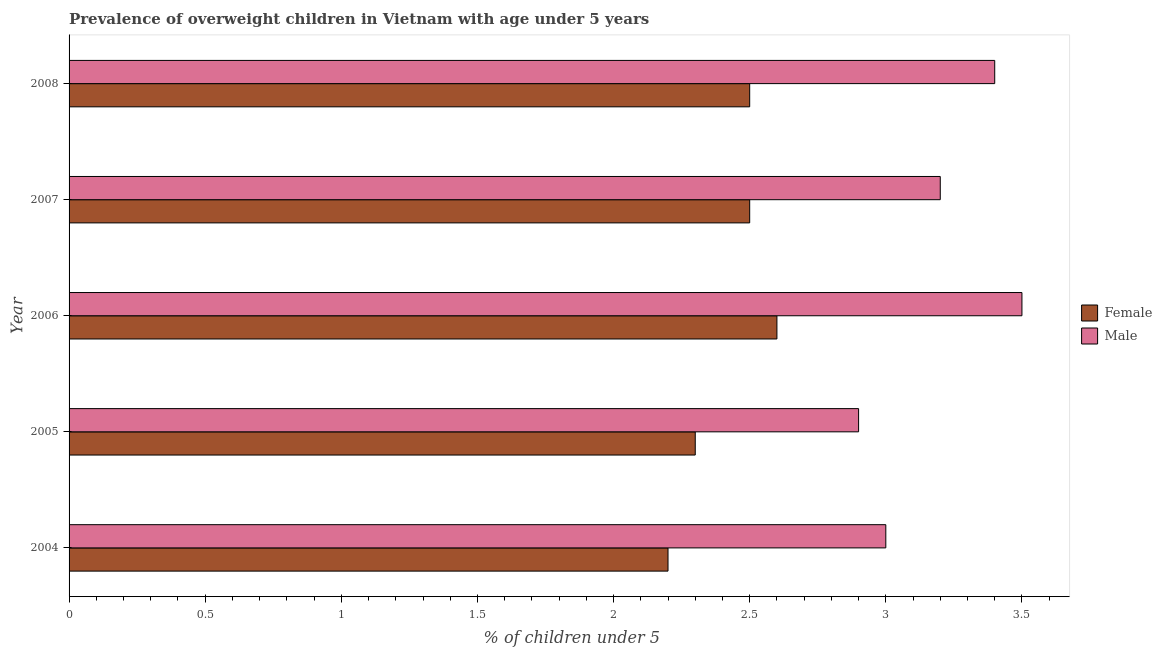Are the number of bars on each tick of the Y-axis equal?
Your response must be concise. Yes. How many bars are there on the 5th tick from the bottom?
Keep it short and to the point. 2. In how many cases, is the number of bars for a given year not equal to the number of legend labels?
Give a very brief answer. 0. What is the percentage of obese female children in 2008?
Provide a short and direct response. 2.5. Across all years, what is the maximum percentage of obese female children?
Give a very brief answer. 2.6. Across all years, what is the minimum percentage of obese male children?
Your answer should be very brief. 2.9. In which year was the percentage of obese male children minimum?
Your answer should be very brief. 2005. What is the total percentage of obese male children in the graph?
Provide a succinct answer. 16. What is the difference between the percentage of obese female children in 2005 and the percentage of obese male children in 2004?
Make the answer very short. -0.7. In how many years, is the percentage of obese male children greater than 0.9 %?
Give a very brief answer. 5. Is the difference between the percentage of obese male children in 2007 and 2008 greater than the difference between the percentage of obese female children in 2007 and 2008?
Provide a succinct answer. No. What is the difference between the highest and the lowest percentage of obese female children?
Your answer should be very brief. 0.4. In how many years, is the percentage of obese male children greater than the average percentage of obese male children taken over all years?
Provide a short and direct response. 3. Is the sum of the percentage of obese male children in 2004 and 2008 greater than the maximum percentage of obese female children across all years?
Ensure brevity in your answer.  Yes. What does the 1st bar from the bottom in 2006 represents?
Your response must be concise. Female. How many bars are there?
Keep it short and to the point. 10. Are all the bars in the graph horizontal?
Offer a very short reply. Yes. Are the values on the major ticks of X-axis written in scientific E-notation?
Provide a succinct answer. No. Does the graph contain any zero values?
Make the answer very short. No. Does the graph contain grids?
Provide a short and direct response. No. Where does the legend appear in the graph?
Provide a short and direct response. Center right. What is the title of the graph?
Give a very brief answer. Prevalence of overweight children in Vietnam with age under 5 years. Does "Female" appear as one of the legend labels in the graph?
Provide a succinct answer. Yes. What is the label or title of the X-axis?
Give a very brief answer.  % of children under 5. What is the  % of children under 5 in Female in 2004?
Your answer should be compact. 2.2. What is the  % of children under 5 in Female in 2005?
Offer a terse response. 2.3. What is the  % of children under 5 in Male in 2005?
Make the answer very short. 2.9. What is the  % of children under 5 of Female in 2006?
Your answer should be compact. 2.6. What is the  % of children under 5 in Female in 2007?
Provide a short and direct response. 2.5. What is the  % of children under 5 of Male in 2007?
Provide a succinct answer. 3.2. What is the  % of children under 5 of Male in 2008?
Offer a terse response. 3.4. Across all years, what is the maximum  % of children under 5 of Female?
Offer a very short reply. 2.6. Across all years, what is the maximum  % of children under 5 of Male?
Offer a terse response. 3.5. Across all years, what is the minimum  % of children under 5 in Female?
Your answer should be compact. 2.2. Across all years, what is the minimum  % of children under 5 of Male?
Provide a succinct answer. 2.9. What is the total  % of children under 5 of Female in the graph?
Your answer should be compact. 12.1. What is the difference between the  % of children under 5 of Female in 2004 and that in 2005?
Ensure brevity in your answer.  -0.1. What is the difference between the  % of children under 5 in Female in 2004 and that in 2006?
Offer a terse response. -0.4. What is the difference between the  % of children under 5 in Male in 2004 and that in 2006?
Keep it short and to the point. -0.5. What is the difference between the  % of children under 5 of Female in 2004 and that in 2007?
Provide a succinct answer. -0.3. What is the difference between the  % of children under 5 of Male in 2004 and that in 2007?
Ensure brevity in your answer.  -0.2. What is the difference between the  % of children under 5 in Female in 2005 and that in 2006?
Your answer should be compact. -0.3. What is the difference between the  % of children under 5 of Female in 2005 and that in 2007?
Offer a terse response. -0.2. What is the difference between the  % of children under 5 in Female in 2005 and that in 2008?
Make the answer very short. -0.2. What is the difference between the  % of children under 5 of Male in 2005 and that in 2008?
Make the answer very short. -0.5. What is the difference between the  % of children under 5 of Male in 2006 and that in 2007?
Your response must be concise. 0.3. What is the difference between the  % of children under 5 of Female in 2006 and that in 2008?
Offer a terse response. 0.1. What is the difference between the  % of children under 5 in Female in 2004 and the  % of children under 5 in Male in 2006?
Your answer should be compact. -1.3. What is the difference between the  % of children under 5 of Female in 2005 and the  % of children under 5 of Male in 2008?
Offer a terse response. -1.1. What is the difference between the  % of children under 5 of Female in 2006 and the  % of children under 5 of Male in 2007?
Provide a succinct answer. -0.6. What is the difference between the  % of children under 5 of Female in 2006 and the  % of children under 5 of Male in 2008?
Offer a terse response. -0.8. What is the difference between the  % of children under 5 of Female in 2007 and the  % of children under 5 of Male in 2008?
Provide a succinct answer. -0.9. What is the average  % of children under 5 in Female per year?
Your answer should be very brief. 2.42. In the year 2007, what is the difference between the  % of children under 5 in Female and  % of children under 5 in Male?
Offer a very short reply. -0.7. In the year 2008, what is the difference between the  % of children under 5 of Female and  % of children under 5 of Male?
Provide a succinct answer. -0.9. What is the ratio of the  % of children under 5 of Female in 2004 to that in 2005?
Ensure brevity in your answer.  0.96. What is the ratio of the  % of children under 5 in Male in 2004 to that in 2005?
Ensure brevity in your answer.  1.03. What is the ratio of the  % of children under 5 of Female in 2004 to that in 2006?
Give a very brief answer. 0.85. What is the ratio of the  % of children under 5 in Male in 2004 to that in 2006?
Your answer should be very brief. 0.86. What is the ratio of the  % of children under 5 in Female in 2004 to that in 2007?
Your response must be concise. 0.88. What is the ratio of the  % of children under 5 in Female in 2004 to that in 2008?
Your response must be concise. 0.88. What is the ratio of the  % of children under 5 in Male in 2004 to that in 2008?
Offer a terse response. 0.88. What is the ratio of the  % of children under 5 of Female in 2005 to that in 2006?
Provide a short and direct response. 0.88. What is the ratio of the  % of children under 5 of Male in 2005 to that in 2006?
Ensure brevity in your answer.  0.83. What is the ratio of the  % of children under 5 of Female in 2005 to that in 2007?
Your answer should be compact. 0.92. What is the ratio of the  % of children under 5 in Male in 2005 to that in 2007?
Your answer should be very brief. 0.91. What is the ratio of the  % of children under 5 of Female in 2005 to that in 2008?
Provide a succinct answer. 0.92. What is the ratio of the  % of children under 5 in Male in 2005 to that in 2008?
Keep it short and to the point. 0.85. What is the ratio of the  % of children under 5 in Male in 2006 to that in 2007?
Your answer should be compact. 1.09. What is the ratio of the  % of children under 5 of Male in 2006 to that in 2008?
Provide a short and direct response. 1.03. What is the difference between the highest and the second highest  % of children under 5 in Female?
Provide a succinct answer. 0.1. What is the difference between the highest and the lowest  % of children under 5 of Male?
Provide a short and direct response. 0.6. 